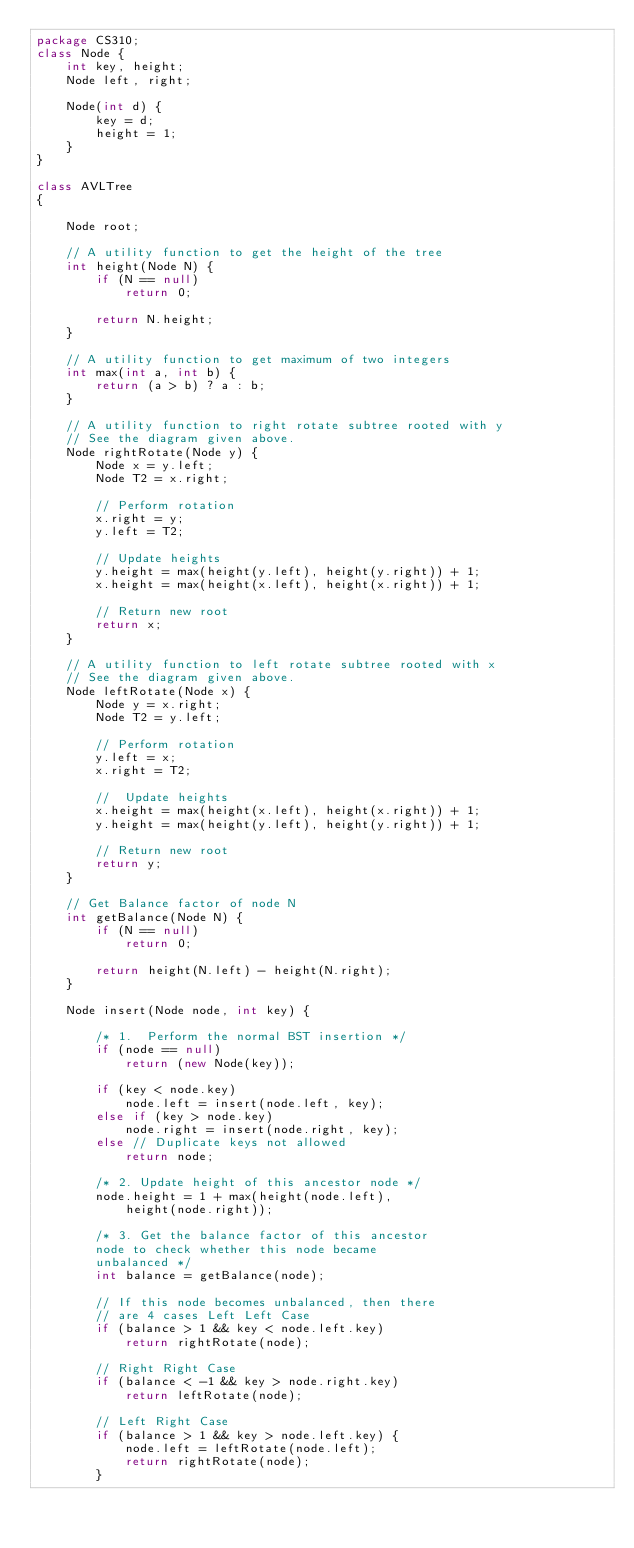Convert code to text. <code><loc_0><loc_0><loc_500><loc_500><_Java_>package CS310;
class Node { 
    int key, height; 
    Node left, right; 

    Node(int d) { 
        key = d; 
        height = 1; 
    } 
} 

class AVLTree 
{ 

    Node root; 

    // A utility function to get the height of the tree 
    int height(Node N) { 
        if (N == null) 
            return 0; 

        return N.height; 
    } 

    // A utility function to get maximum of two integers 
    int max(int a, int b) { 
        return (a > b) ? a : b; 
    } 

    // A utility function to right rotate subtree rooted with y 
    // See the diagram given above. 
    Node rightRotate(Node y) { 
        Node x = y.left; 
        Node T2 = x.right; 

        // Perform rotation 
        x.right = y; 
        y.left = T2; 

        // Update heights 
        y.height = max(height(y.left), height(y.right)) + 1; 
        x.height = max(height(x.left), height(x.right)) + 1; 

        // Return new root 
        return x; 
    } 

    // A utility function to left rotate subtree rooted with x 
    // See the diagram given above. 
    Node leftRotate(Node x) { 
        Node y = x.right; 
        Node T2 = y.left; 

        // Perform rotation 
        y.left = x; 
        x.right = T2; 

        //  Update heights 
        x.height = max(height(x.left), height(x.right)) + 1; 
        y.height = max(height(y.left), height(y.right)) + 1; 

        // Return new root 
        return y; 
    } 

    // Get Balance factor of node N 
    int getBalance(Node N) { 
        if (N == null) 
            return 0; 

        return height(N.left) - height(N.right); 
    } 

    Node insert(Node node, int key) { 

        /* 1.  Perform the normal BST insertion */
        if (node == null) 
            return (new Node(key)); 

        if (key < node.key) 
            node.left = insert(node.left, key); 
        else if (key > node.key) 
            node.right = insert(node.right, key); 
        else // Duplicate keys not allowed 
            return node; 

        /* 2. Update height of this ancestor node */
        node.height = 1 + max(height(node.left), 
            height(node.right)); 

        /* 3. Get the balance factor of this ancestor 
        node to check whether this node became 
        unbalanced */
        int balance = getBalance(node); 

        // If this node becomes unbalanced, then there 
        // are 4 cases Left Left Case 
        if (balance > 1 && key < node.left.key) 
            return rightRotate(node); 

        // Right Right Case 
        if (balance < -1 && key > node.right.key) 
            return leftRotate(node); 

        // Left Right Case 
        if (balance > 1 && key > node.left.key) { 
            node.left = leftRotate(node.left); 
            return rightRotate(node); 
        } 
</code> 